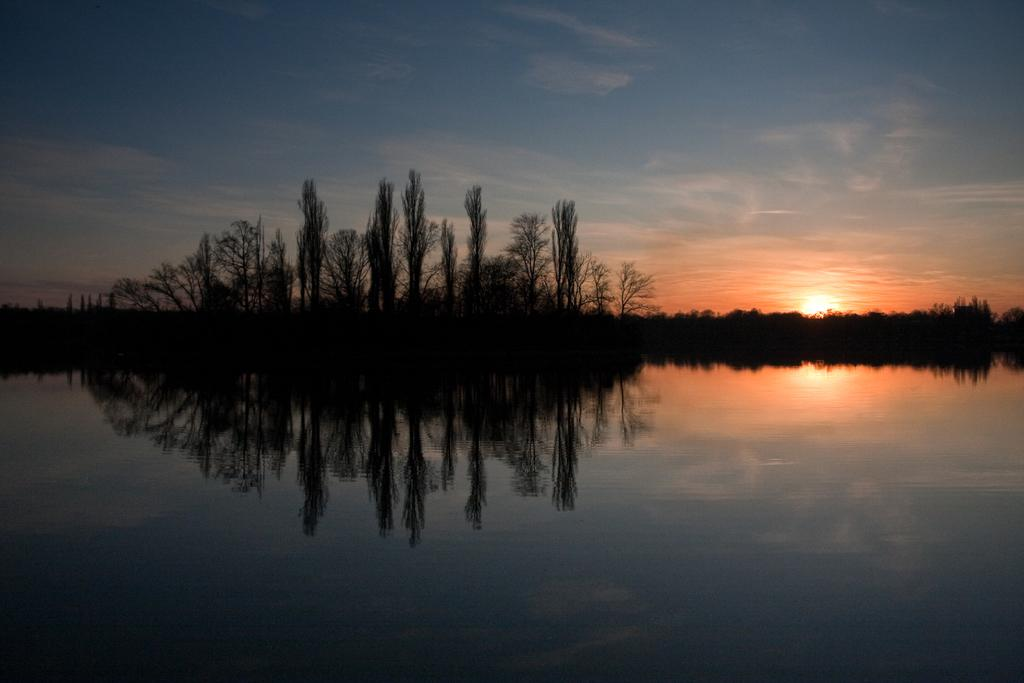What is in the foreground of the image? There is water in the foreground of the image. What can be seen in the background of the image? There are trees, the sun, sky, and a cloud visible in the background of the image. Where is the harbor located in the image? There is no harbor present in the image. What type of coach can be seen driving through the trees in the background? There is no coach present in the image; only trees, the sun, sky, and a cloud are visible in the background. 